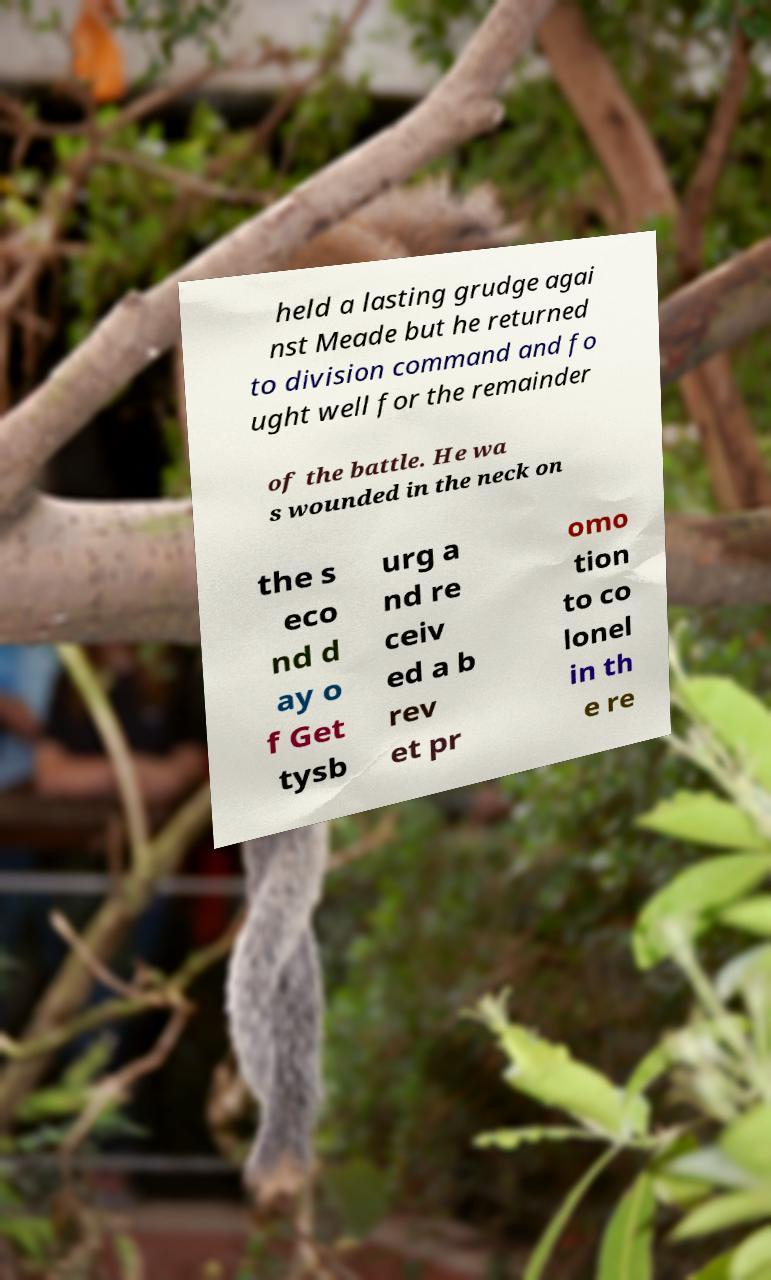Can you accurately transcribe the text from the provided image for me? held a lasting grudge agai nst Meade but he returned to division command and fo ught well for the remainder of the battle. He wa s wounded in the neck on the s eco nd d ay o f Get tysb urg a nd re ceiv ed a b rev et pr omo tion to co lonel in th e re 